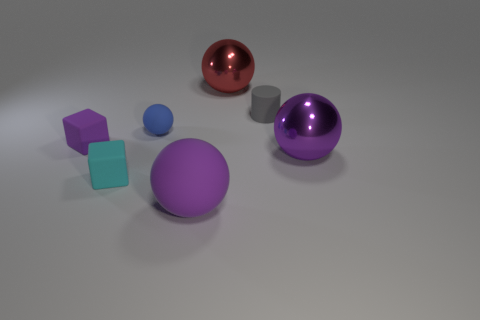Add 3 cyan cubes. How many objects exist? 10 Subtract all cylinders. How many objects are left? 6 Subtract all blue rubber spheres. Subtract all purple blocks. How many objects are left? 5 Add 7 purple matte balls. How many purple matte balls are left? 8 Add 7 purple rubber spheres. How many purple rubber spheres exist? 8 Subtract 0 green balls. How many objects are left? 7 